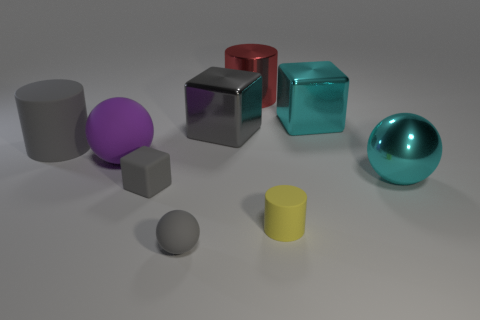Do the rubber cube and the large matte cylinder have the same color?
Offer a terse response. Yes. There is a large matte object that is the same color as the tiny cube; what shape is it?
Make the answer very short. Cylinder. Does the large shiny sphere have the same color as the big block on the right side of the yellow thing?
Provide a succinct answer. Yes. How many other things are the same size as the shiny cylinder?
Give a very brief answer. 5. There is a gray thing that is in front of the matte cube; is its shape the same as the purple rubber object?
Offer a terse response. Yes. Is the number of gray things that are in front of the gray matte cylinder greater than the number of big cyan rubber balls?
Make the answer very short. Yes. There is a cylinder that is both on the right side of the purple rubber sphere and in front of the big gray cube; what is its material?
Offer a terse response. Rubber. What number of tiny things are both on the right side of the tiny cube and behind the yellow matte cylinder?
Ensure brevity in your answer.  0. What is the big purple sphere made of?
Provide a short and direct response. Rubber. Is the number of tiny yellow cylinders left of the purple thing the same as the number of large gray spheres?
Your response must be concise. Yes. 